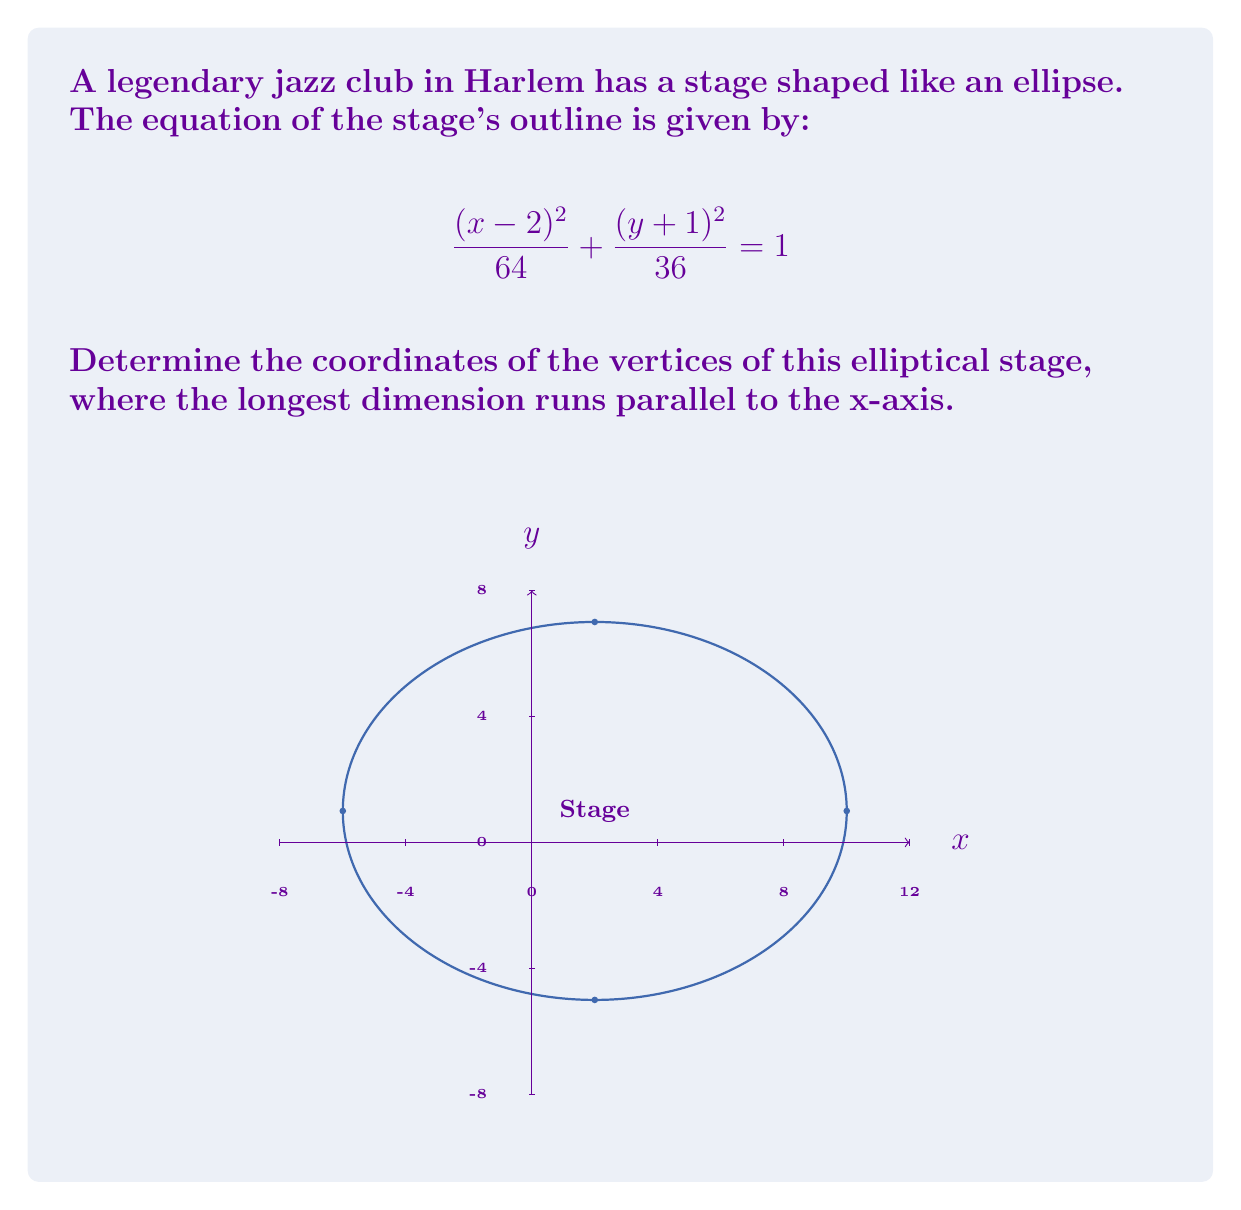Help me with this question. To find the vertices of the ellipse, we need to follow these steps:

1) First, identify the center of the ellipse. The general form of an ellipse equation is:

   $$\frac{(x-h)^2}{a^2} + \frac{(y-k)^2}{b^2} = 1$$

   where (h,k) is the center of the ellipse.

2) Comparing our equation to the general form, we can see that:
   h = 2 and k = -1
   So, the center of the ellipse is at (2, -1).

3) Next, identify the values of a and b:
   $a^2 = 64$, so $a = 8$
   $b^2 = 36$, so $b = 6$

4) For an ellipse with its longest dimension parallel to the x-axis, a > b. This is true in our case.

5) The vertices of an ellipse are located a units away from the center along the major axis. In this case, the major axis is horizontal (parallel to x-axis).

6) To find the x-coordinates of the vertices:
   x = h ± a
   x = 2 ± 8

7) Therefore, the vertices are located at:
   (2 + 8, -1) = (10, -1)
   (2 - 8, -1) = (-6, -1)
Answer: (-6, -1) and (10, -1) 